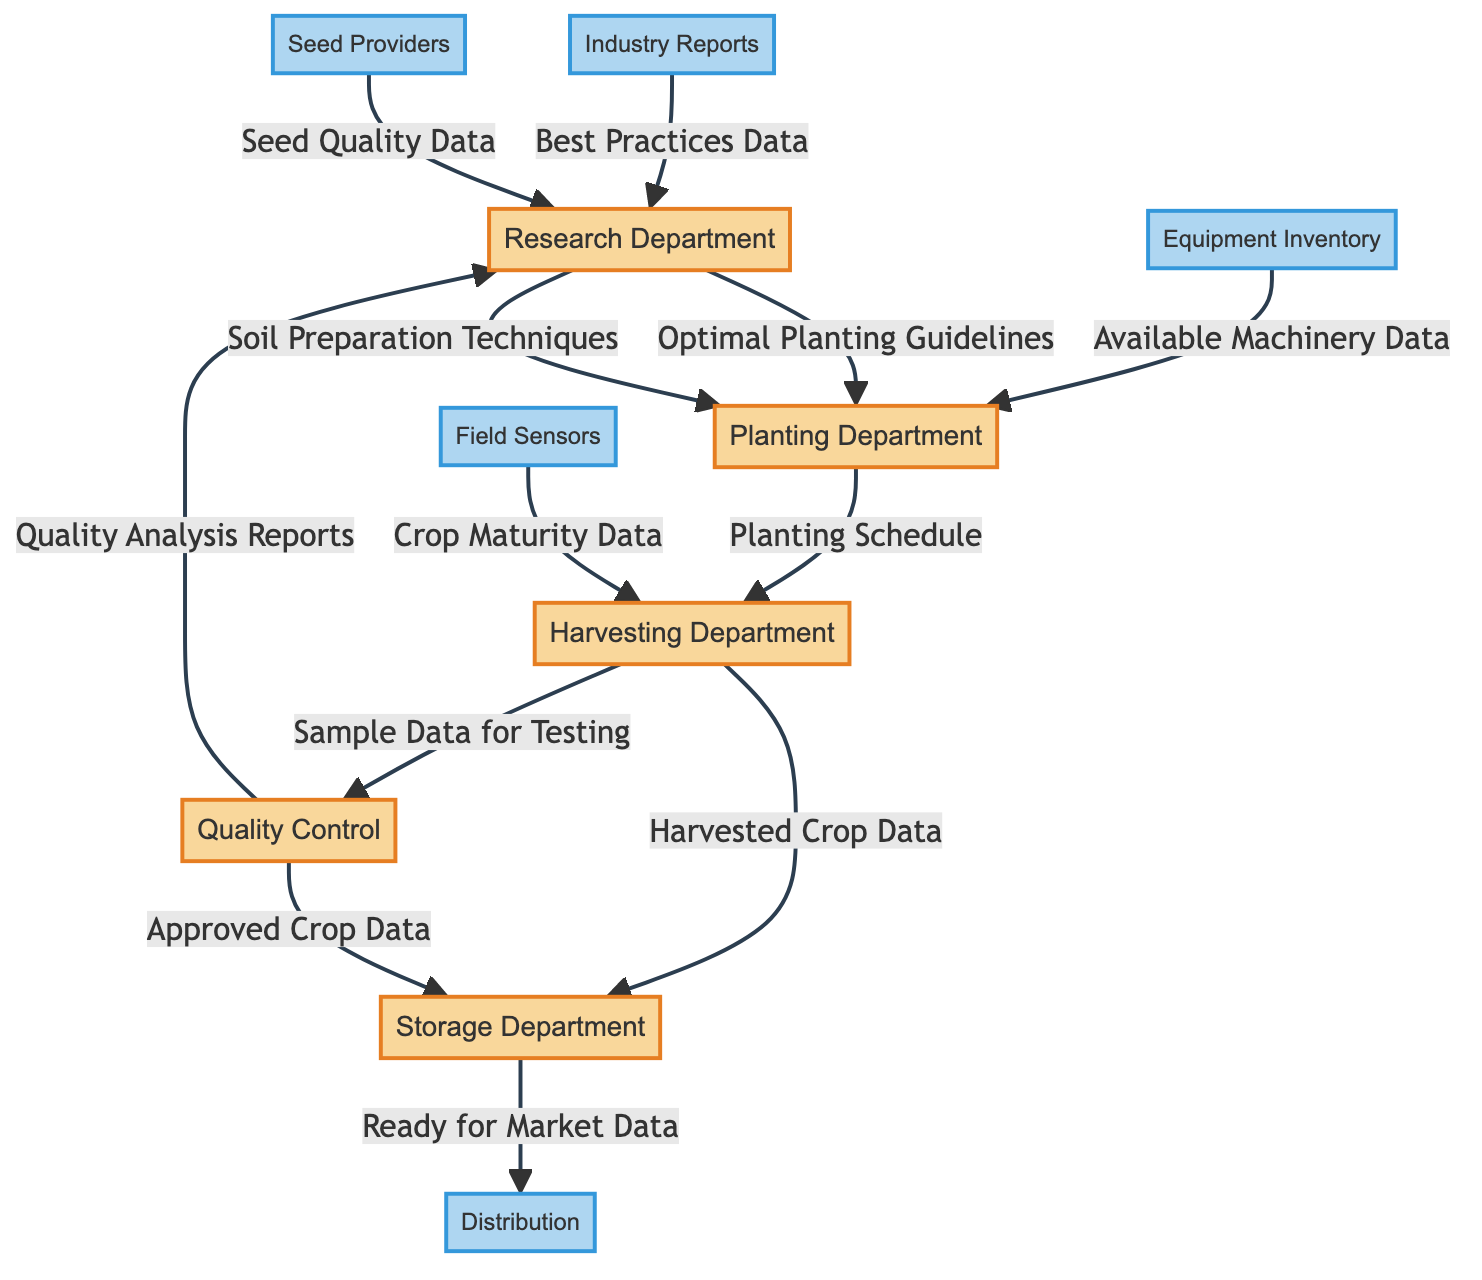What is the first input to the Research Department? The first input to the Research Department comes from Industry Reports and is labeled as Best Practices Data.
Answer: Best Practices Data How many departments are involved in the crop production lifecycle management? The diagram indicates there are five departments involved: Research Department, Planting Department, Harvesting Department, Storage Department, and Quality Control.
Answer: Five What data does the Harvesting Department send to the Storage Department? The Harvesting Department sends the Harvested Crop Data to the Storage Department as an output.
Answer: Harvested Crop Data Which department receives the Sample Data for Testing from the Harvesting Department? The Quality Control department receives the Sample Data for Testing from the Harvesting Department.
Answer: Quality Control What is the output of the Storage Department? The Storage Department's output is labeled as Ready for Market Data, which is sent to the Distribution node.
Answer: Ready for Market Data What kind of data does the Planting Department utilize from the Research Department? The Planting Department uses Optimal Planting Guidelines and Soil Preparation Techniques from the Research Department as inputs.
Answer: Optimal Planting Guidelines and Soil Preparation Techniques Which department analyzes the Sample Data for Testing? The Quality Control department is responsible for analyzing the Sample Data for Testing received from the Harvesting Department.
Answer: Quality Control How many types of input does the Planting Department receive? The Planting Department receives three types of input: Optimal Planting Guidelines, Soil Preparation Techniques, and Available Machinery Data.
Answer: Three What is the final destination of data from the Storage Department? The final destination of data from the Storage Department is Distribution, where it provides the Ready for Market Data.
Answer: Distribution 